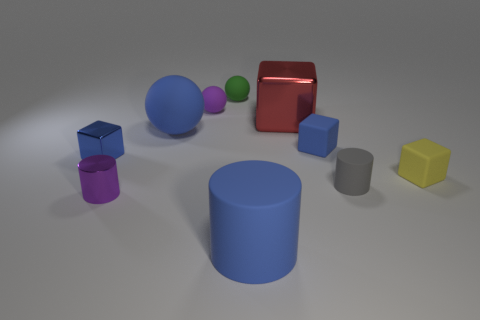Is the number of yellow matte things left of the purple metallic cylinder greater than the number of objects that are right of the blue matte block?
Your response must be concise. No. What shape is the blue matte object that is right of the shiny cube behind the metal cube to the left of the purple metallic cylinder?
Give a very brief answer. Cube. What shape is the small thing behind the tiny ball on the left side of the tiny green ball?
Your response must be concise. Sphere. What size is the matte block that is the same color as the big rubber cylinder?
Provide a short and direct response. Small. What number of red things are tiny matte cylinders or tiny metal cubes?
Provide a short and direct response. 0. Is there another tiny cylinder that has the same color as the metallic cylinder?
Offer a very short reply. No. What is the size of the blue ball that is made of the same material as the small purple ball?
Your response must be concise. Large. How many balls are either small gray rubber things or purple metallic objects?
Offer a very short reply. 0. Is the number of cylinders greater than the number of rubber things?
Offer a very short reply. No. What number of balls are the same size as the red metal cube?
Keep it short and to the point. 1. 